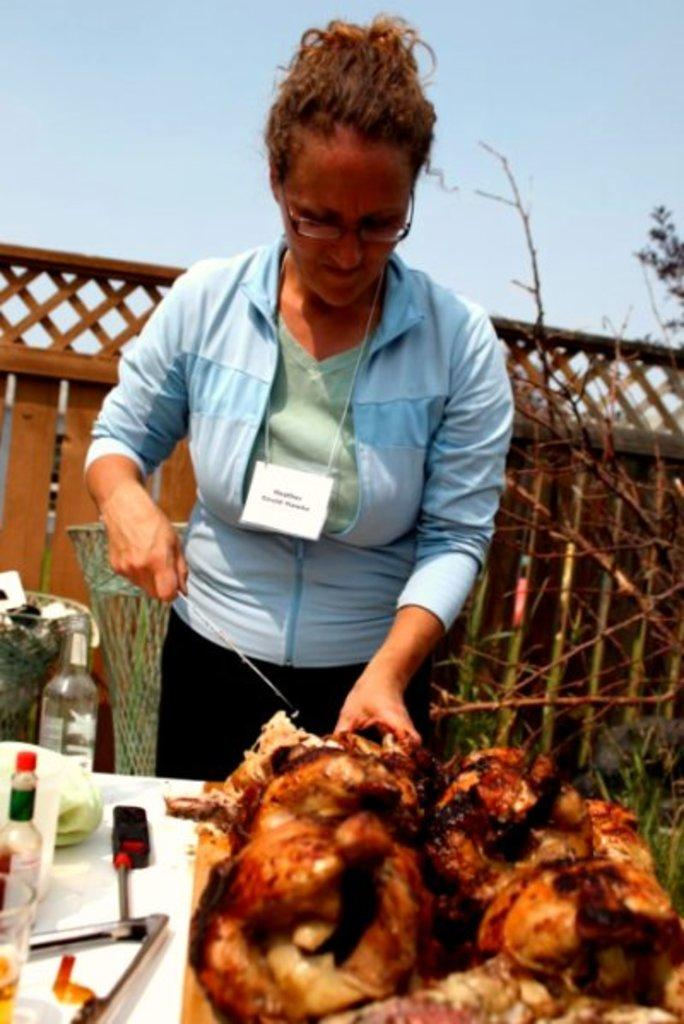What is the woman doing in the image? The woman is standing in the image. What is the woman holding in her hand? The woman is holding something in her hand. What is in front of the woman? There is a table in front of the woman. What can be seen on the table? There are objects on the table. What can be seen in the background of the image? The sky is visible in the image. What type of jeans is the woman wearing in the image? There is no information about the woman's clothing in the image, so we cannot determine if she is wearing jeans or any other type of clothing. 